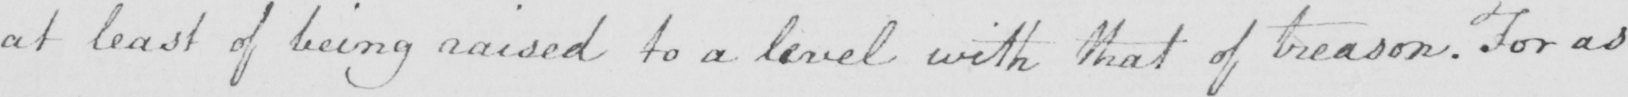Please provide the text content of this handwritten line. at least of being raised to a level with that of treason . For as 